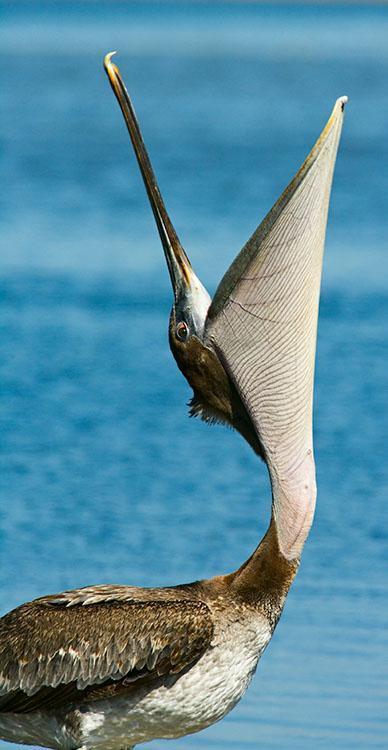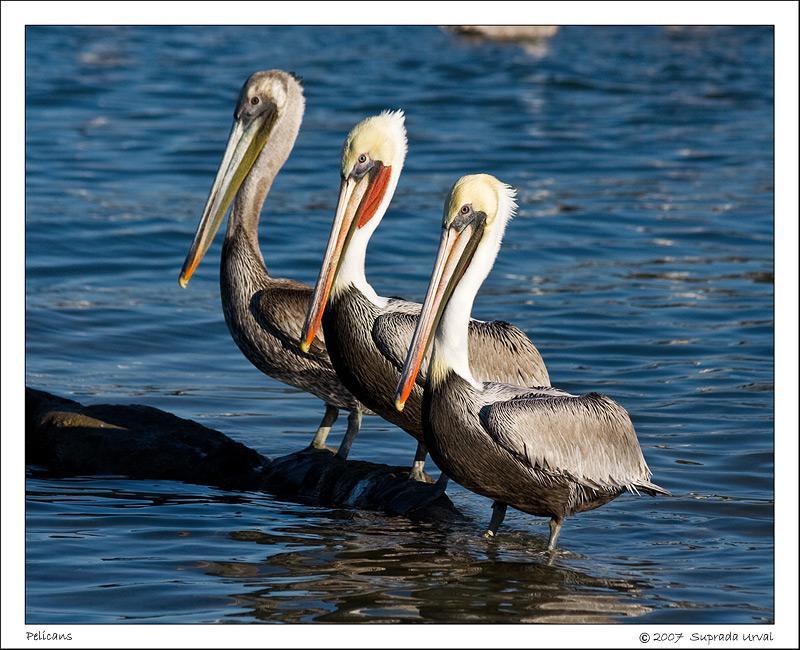The first image is the image on the left, the second image is the image on the right. Examine the images to the left and right. Is the description "The right image contains exactly three birds all looking towards the left." accurate? Answer yes or no. Yes. The first image is the image on the left, the second image is the image on the right. Evaluate the accuracy of this statement regarding the images: "An image contains a trio of similarly posed left-facing pelicans with white heads and grey bodies.". Is it true? Answer yes or no. Yes. 